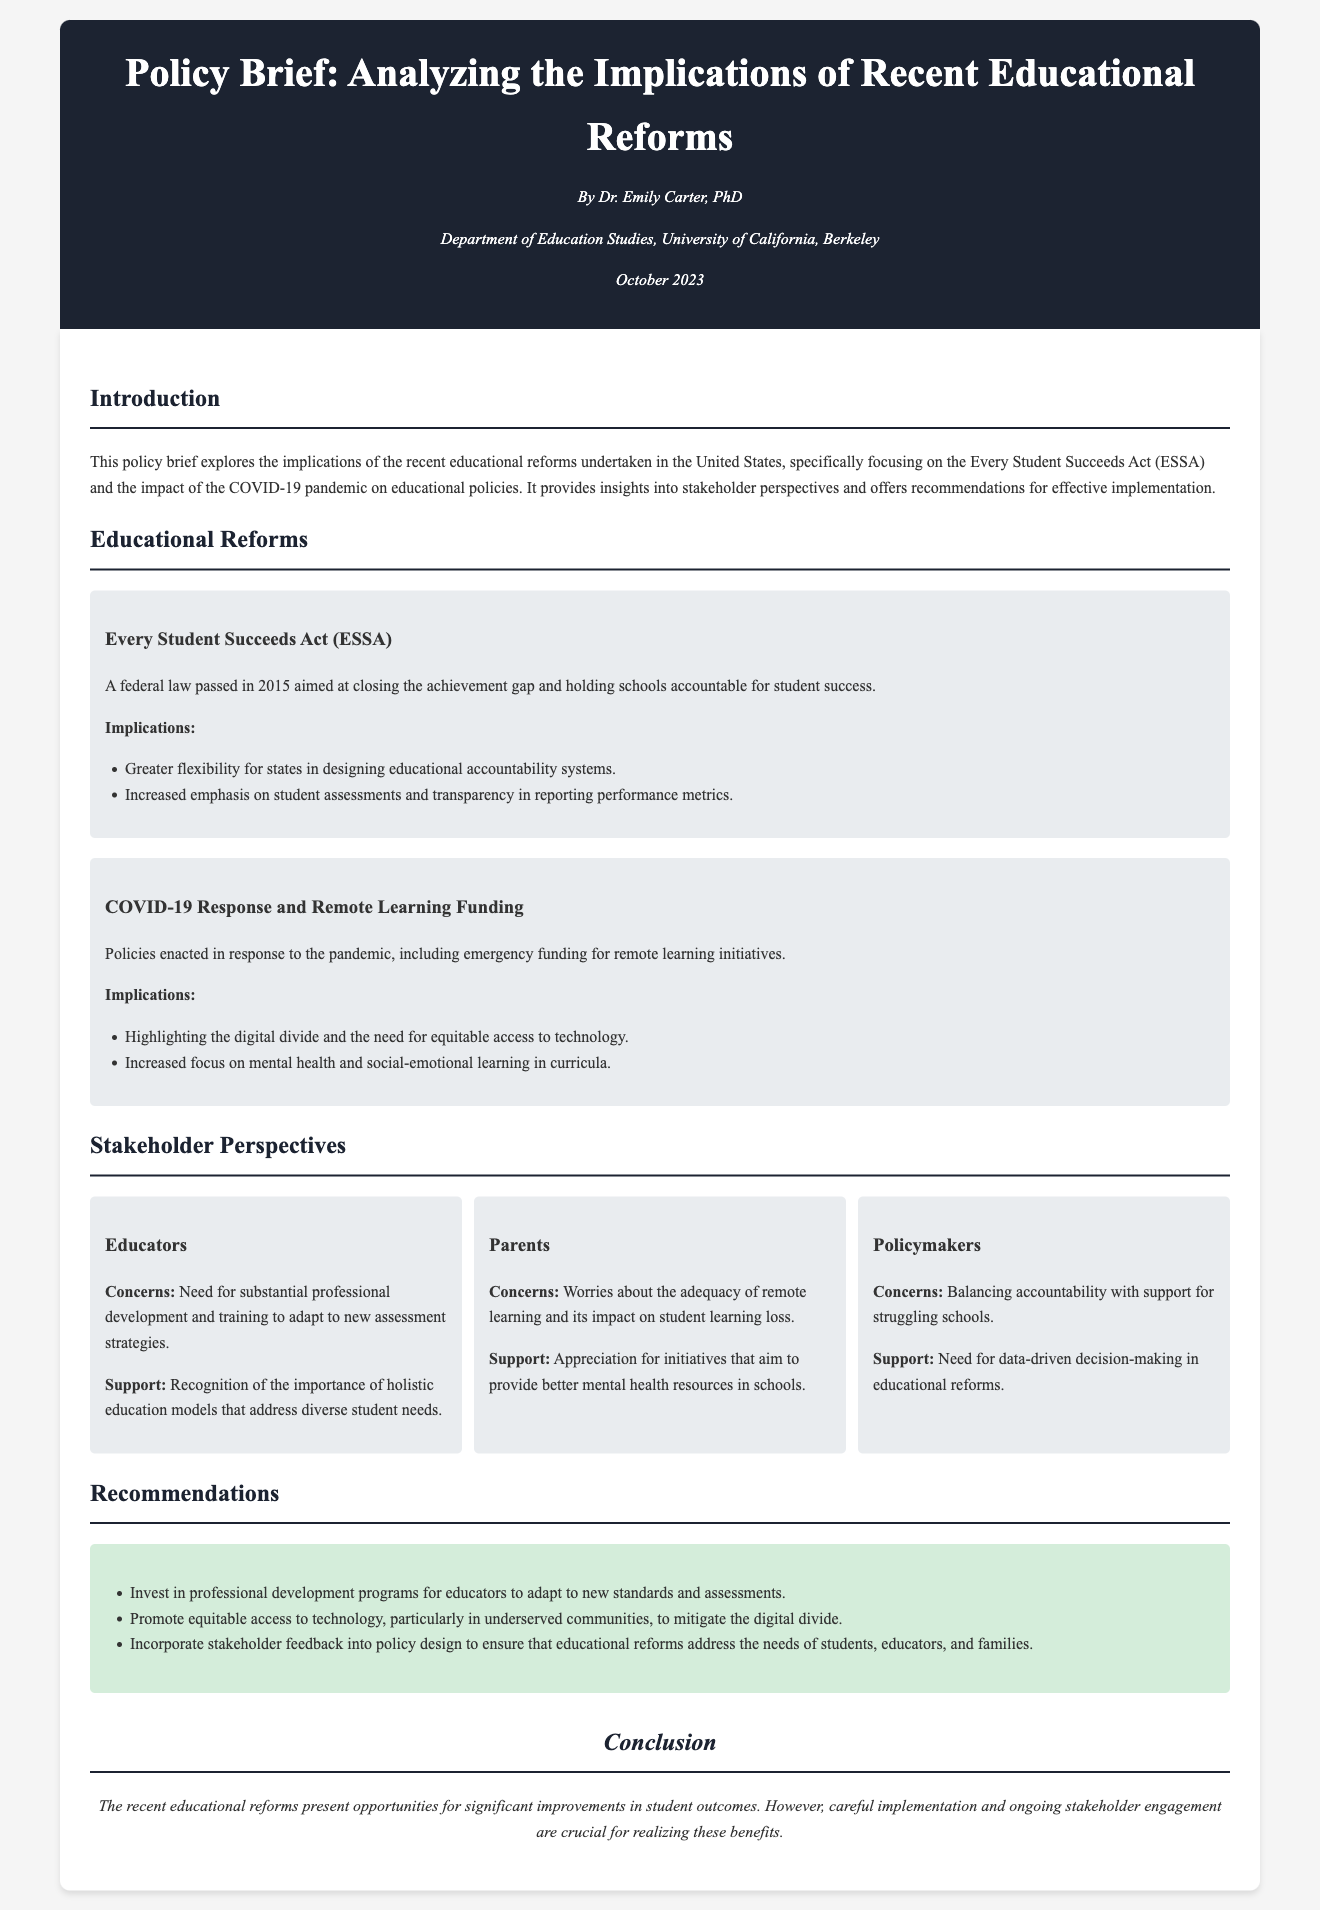What is the title of the policy brief? The title of the policy brief is found in the header section at the beginning of the document.
Answer: Analyzing the Implications of Recent Educational Reforms Who is the author of the policy brief? The author's name is mentioned in the author info section under the title.
Answer: Dr. Emily Carter What act is primarily discussed concerning educational reform? The act is explicitly stated in the educational reforms section of the document.
Answer: Every Student Succeeds Act (ESSA) What is one implication of the COVID-19 response mentioned in the document? The implications are listed under the reform details about COVID-19 response.
Answer: Highlighting the digital divide What do educators express a need for according to stakeholder perspectives? This need is outlined prominently in the educators' section under their concerns.
Answer: Substantial professional development What recommendation is made regarding technology? The recommendations are listed, providing specific guidance on technology access.
Answer: Promote equitable access to technology What date was the policy brief published? The publication date is stated in the author info section of the document.
Answer: October 2023 What is a major concern of parents according to the document? The concern is articulated in the parents' section of stakeholder perspectives.
Answer: Adequacy of remote learning How does the document suggest incorporating stakeholder feedback? The suggestion is found in the recommendations section regarding stakeholder engagement.
Answer: Into policy design 